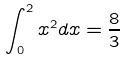<formula> <loc_0><loc_0><loc_500><loc_500>\int _ { 0 } ^ { 2 } x ^ { 2 } d x = \frac { 8 } { 3 }</formula> 